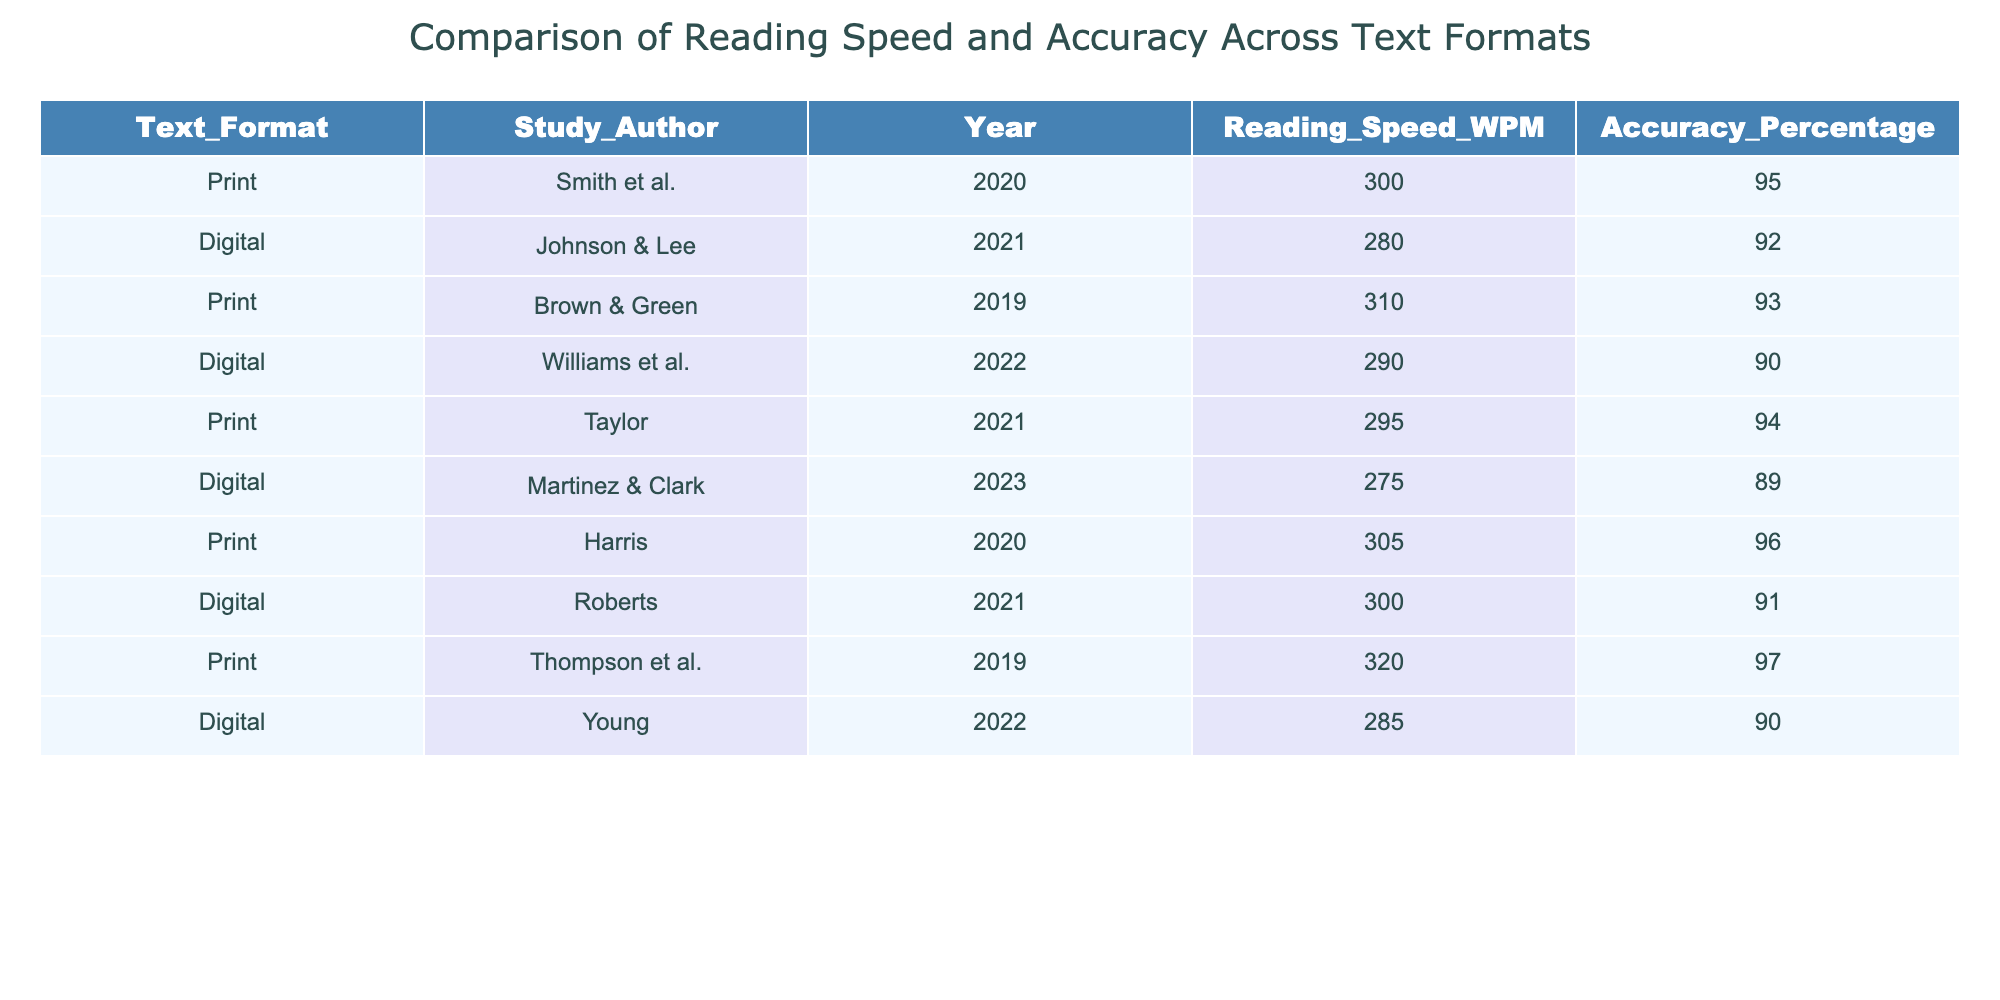What is the reading speed for print texts according to Smith et al. 2020? The table lists the reading speed for print texts as 300 words per minute (WPM) for the study conducted by Smith et al. in 2020.
Answer: 300 WPM What is the accuracy percentage for digital texts in the study by Johnson & Lee? According to the table, Johnson & Lee's study indicates that the accuracy percentage for digital texts is 92%.
Answer: 92% Which text format has higher average reading speed? To find the answer, we calculate the average reading speed for each text format. Print: (300 + 310 + 295 + 305 + 320) / 5 = 306 WPM. Digital: (280 + 290 + 275 + 300 + 285) / 5 = 286 WPM. Since 306 > 286, print has a higher average reading speed.
Answer: Print Is the accuracy percentage for all print studies above 90%? Examining the accuracy percentages for print studies: 95%, 93%, 94%, 96%, and 97% are all above 90%. Thus, the statement is true.
Answer: Yes Which digital study had the lowest accuracy percentage, and what was it? By checking the accuracy percentages for digital studies, Martinez & Clark (2023) has the lowest at 89%.
Answer: Martinez & Clark, 89% What is the difference in reading speed between the highest and lowest print studies? The highest reading speed in print is 320 WPM (from Thompson et al. 2019), and the lowest is 295 WPM (from Taylor 2021). The difference is 320 - 295 = 25 WPM.
Answer: 25 WPM Are the average reading speeds for digital texts comparable to those for print texts? The average reading speed for print texts is 306 WPM, while for digital texts it is 286 WPM. Although they are somewhat close, print is still faster. So they are not fully comparable.
Answer: No What is the total accuracy percentage when combining the digital studies? The accuracy percentages for digital studies are 92%, 90%, 89%, 91%, and 90%. Adding these values gives us: 92 + 90 + 89 + 91 + 90 = 452. To find the average, we divide by the number of studies (5): 452 / 5 = 90.4%.
Answer: 90.4% What do the results suggest about the relationship between text format and reading speed for the studies provided? From the data, print texts consistently show higher reading speeds than digital texts across different studies suggesting that readers may perform better on print.
Answer: Print texts are faster 